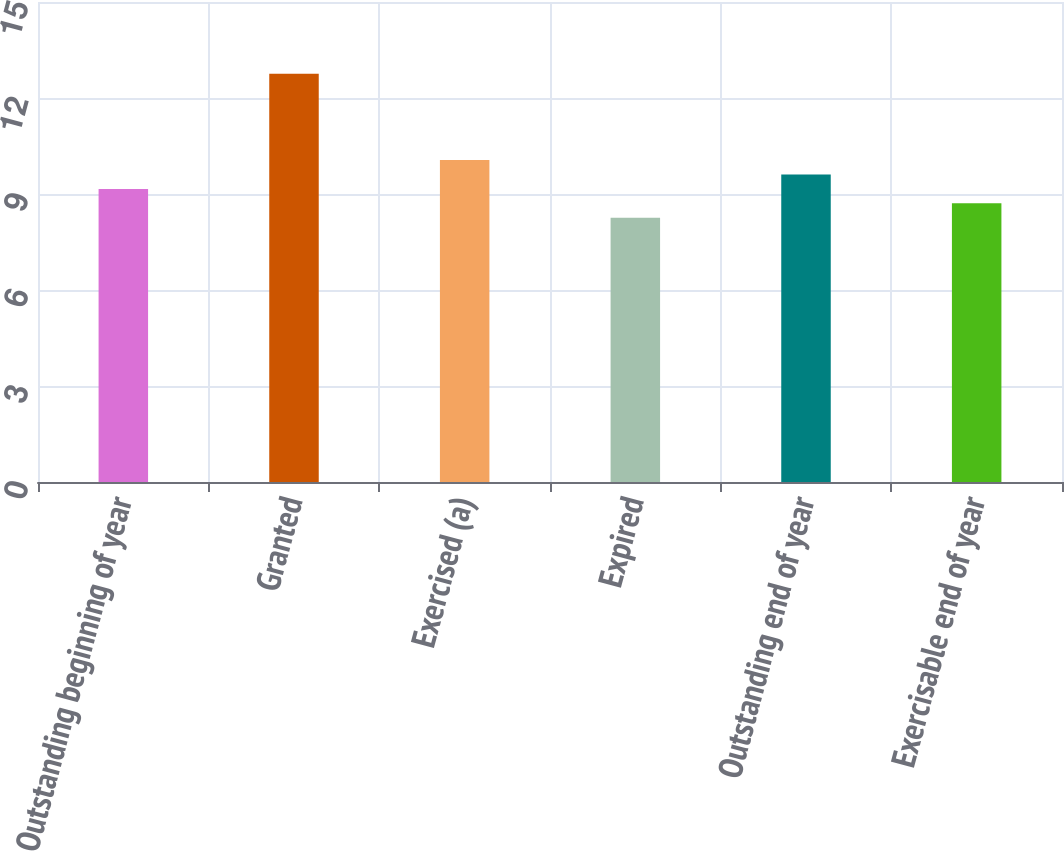Convert chart to OTSL. <chart><loc_0><loc_0><loc_500><loc_500><bar_chart><fcel>Outstanding beginning of year<fcel>Granted<fcel>Exercised (a)<fcel>Expired<fcel>Outstanding end of year<fcel>Exercisable end of year<nl><fcel>9.16<fcel>12.76<fcel>10.06<fcel>8.26<fcel>9.61<fcel>8.71<nl></chart> 